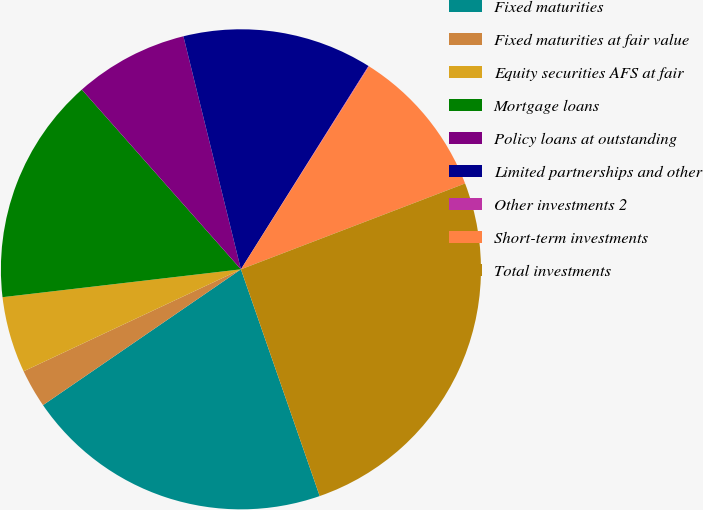<chart> <loc_0><loc_0><loc_500><loc_500><pie_chart><fcel>Fixed maturities<fcel>Fixed maturities at fair value<fcel>Equity securities AFS at fair<fcel>Mortgage loans<fcel>Policy loans at outstanding<fcel>Limited partnerships and other<fcel>Other investments 2<fcel>Short-term investments<fcel>Total investments<nl><fcel>20.75%<fcel>2.59%<fcel>5.13%<fcel>15.32%<fcel>7.68%<fcel>12.77%<fcel>0.04%<fcel>10.22%<fcel>25.5%<nl></chart> 